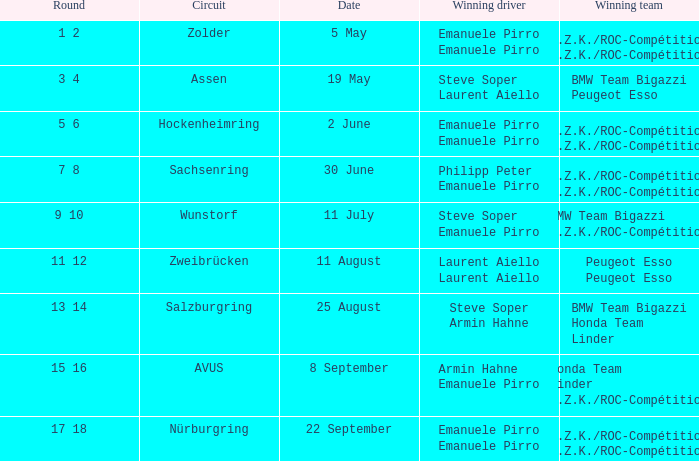Who is the winning driver of the race on 5 May? Emanuele Pirro Emanuele Pirro. 